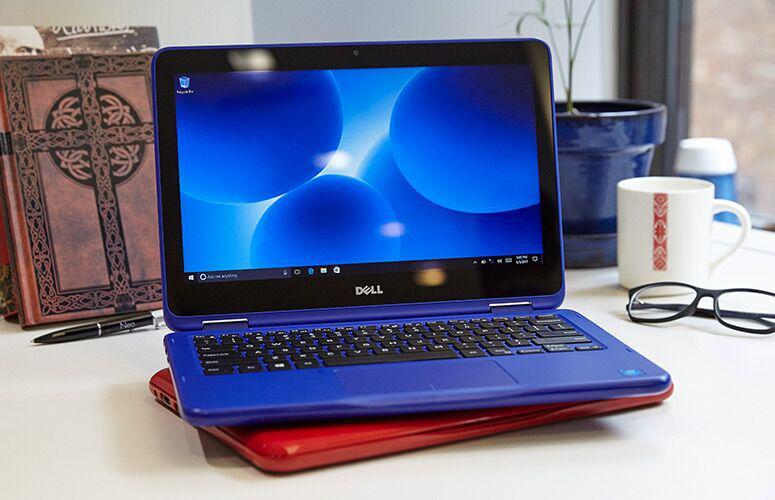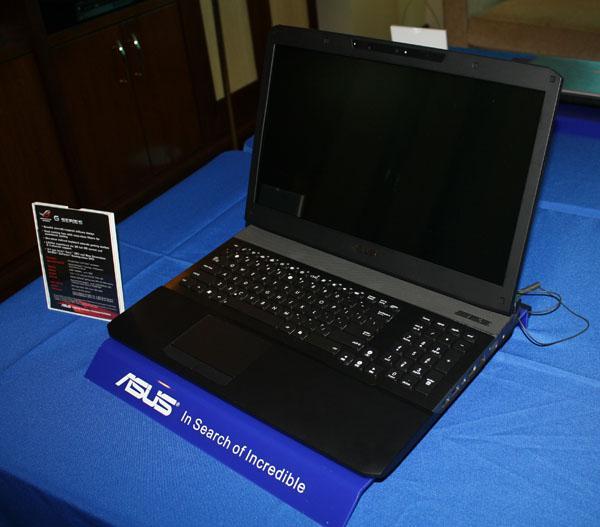The first image is the image on the left, the second image is the image on the right. Examine the images to the left and right. Is the description "The top cover of one laptop is visible." accurate? Answer yes or no. No. The first image is the image on the left, the second image is the image on the right. Assess this claim about the two images: "Two laptops can be seen connected by a crossover cable.". Correct or not? Answer yes or no. No. 